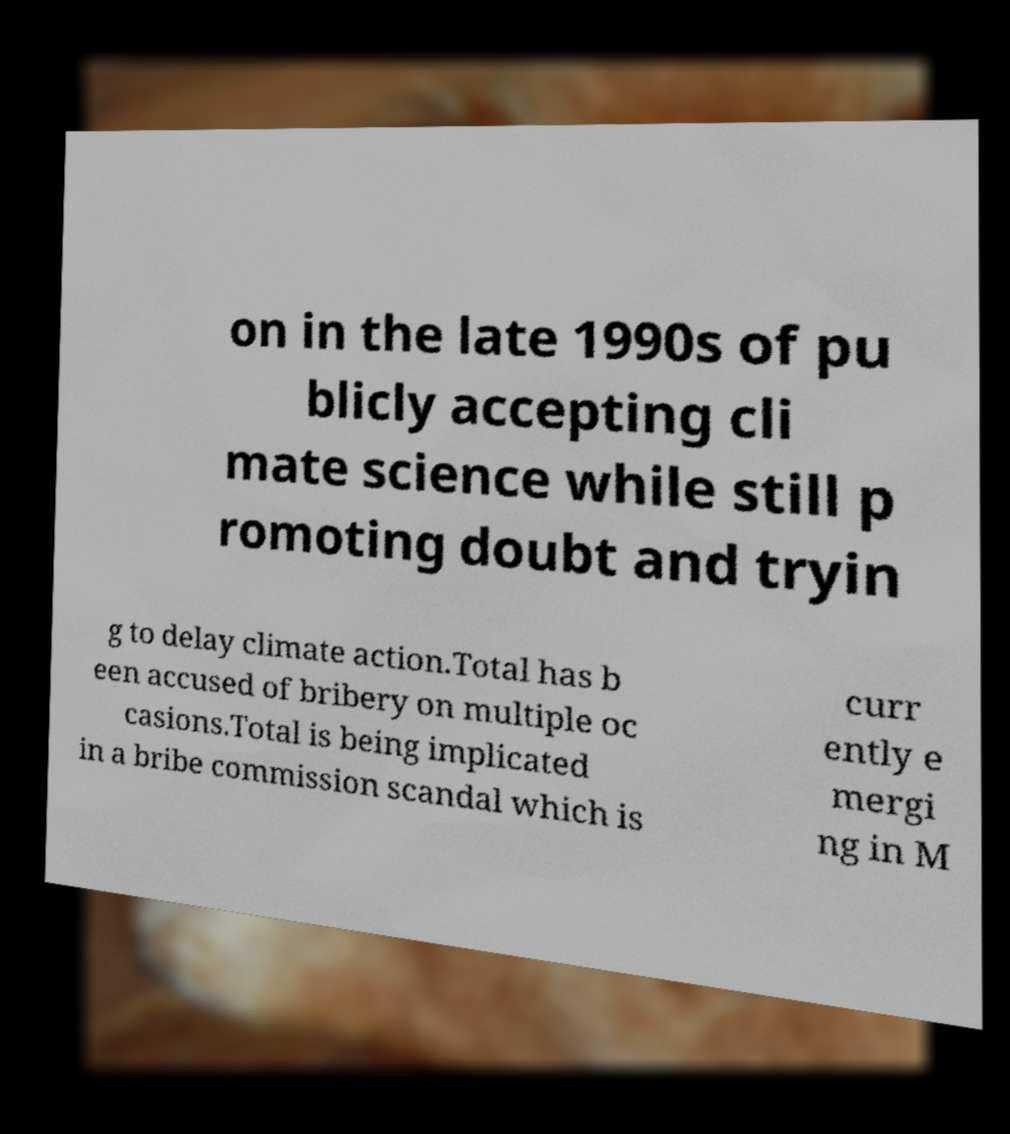For documentation purposes, I need the text within this image transcribed. Could you provide that? on in the late 1990s of pu blicly accepting cli mate science while still p romoting doubt and tryin g to delay climate action.Total has b een accused of bribery on multiple oc casions.Total is being implicated in a bribe commission scandal which is curr ently e mergi ng in M 